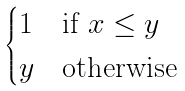Convert formula to latex. <formula><loc_0><loc_0><loc_500><loc_500>\begin{cases} 1 & \text {if} \ x \leq y \\ y & \text {otherwise} \end{cases}</formula> 